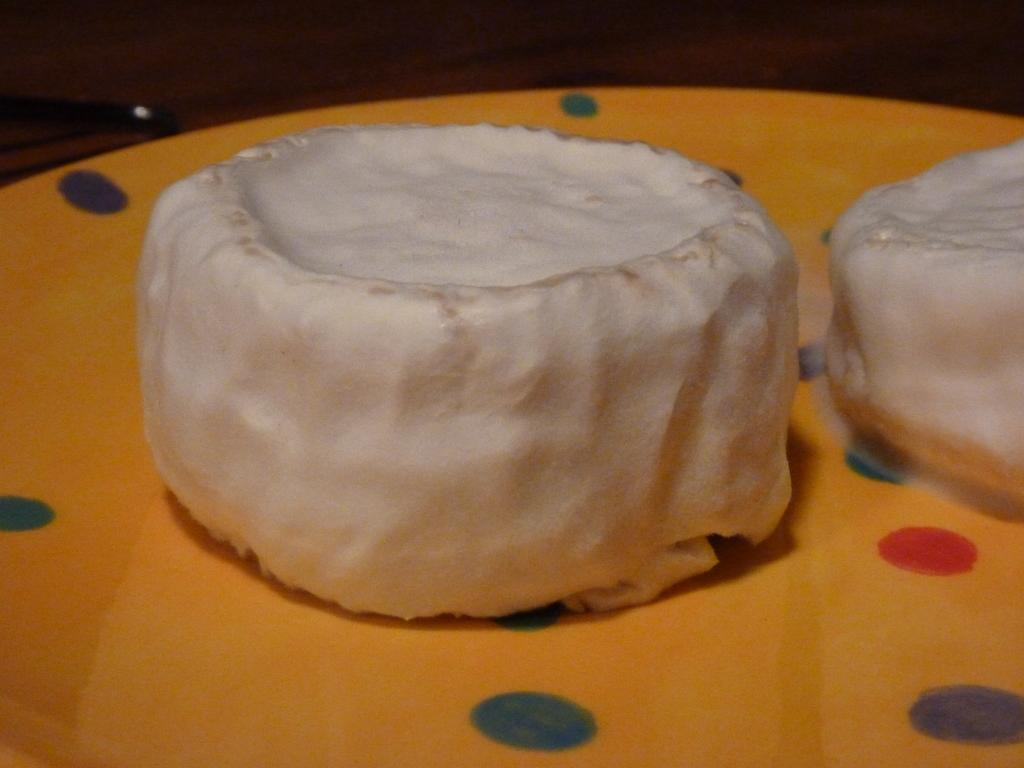What is on the plate that is visible in the image? There is a food item on a plate in the image. What type of curtain can be seen hanging from the food item in the image? There is no curtain present in the image, as it features a food item on a plate. How many roses are visible on the plate in the image? There are no roses present on the plate in the image; it only contains a food item. 